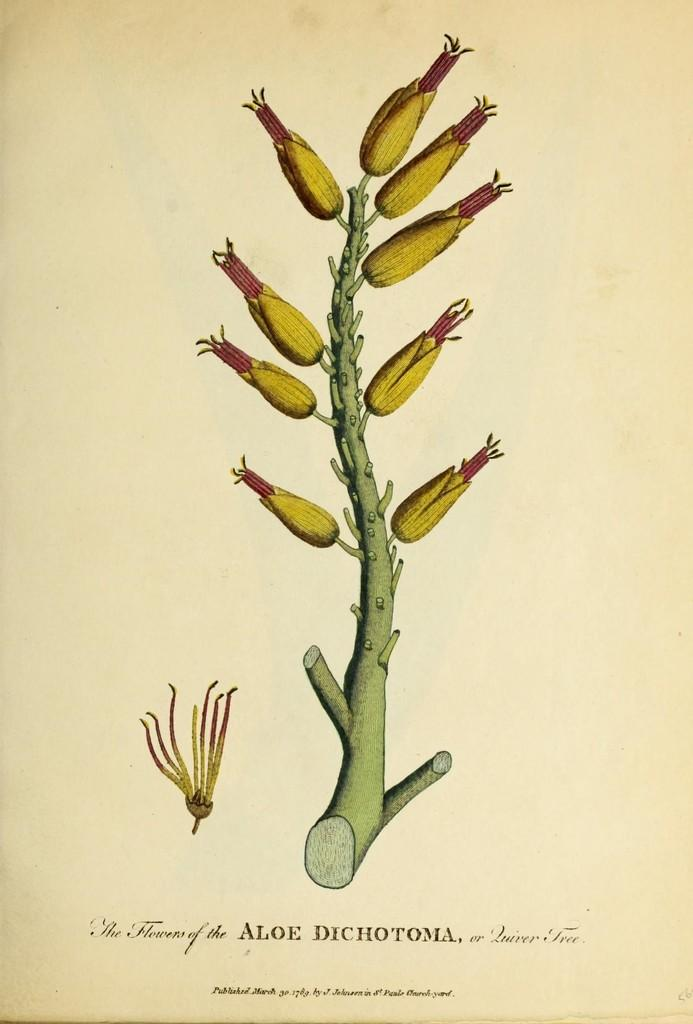What is depicted on the paper in the image? There is a picture of a plant on a paper. What else can be found on the paper besides the picture of the plant? There is text on the paper. What type of lettuce is being used as a shade for the plant in the image? There is no lettuce present in the image, and the plant is depicted on a paper, not in a garden setting. 